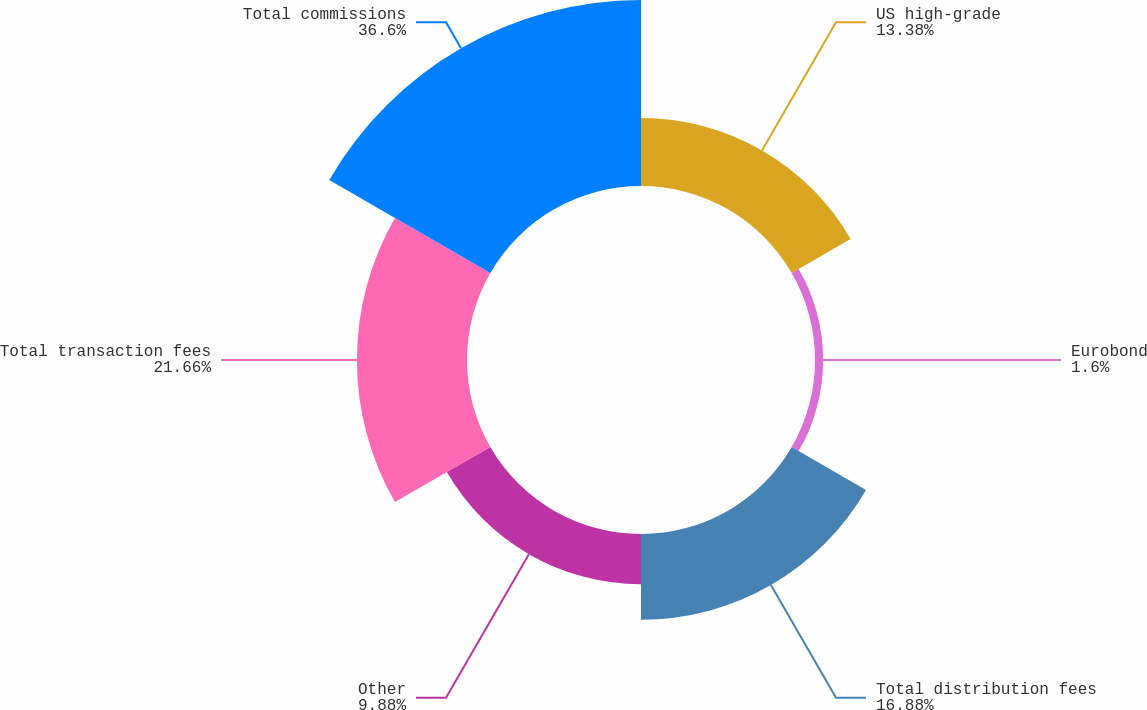Convert chart. <chart><loc_0><loc_0><loc_500><loc_500><pie_chart><fcel>US high-grade<fcel>Eurobond<fcel>Total distribution fees<fcel>Other<fcel>Total transaction fees<fcel>Total commissions<nl><fcel>13.38%<fcel>1.6%<fcel>16.88%<fcel>9.88%<fcel>21.66%<fcel>36.59%<nl></chart> 